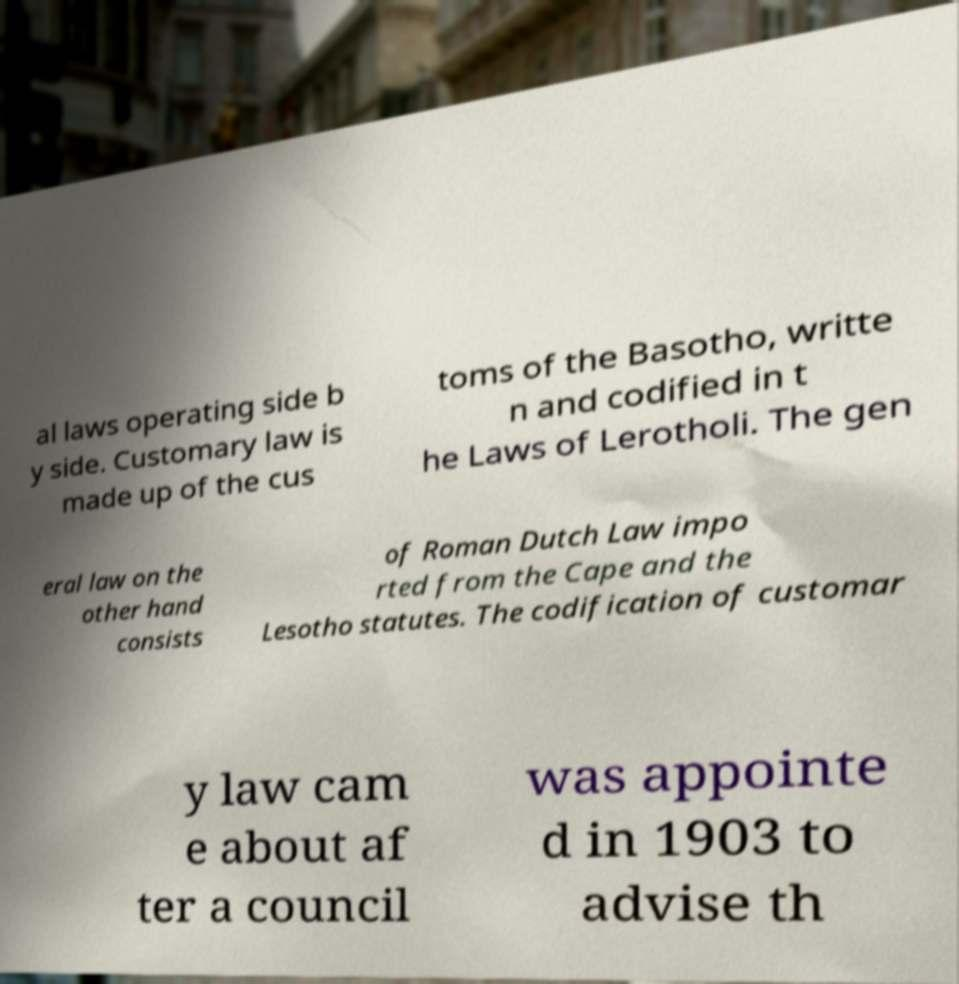Could you extract and type out the text from this image? al laws operating side b y side. Customary law is made up of the cus toms of the Basotho, writte n and codified in t he Laws of Lerotholi. The gen eral law on the other hand consists of Roman Dutch Law impo rted from the Cape and the Lesotho statutes. The codification of customar y law cam e about af ter a council was appointe d in 1903 to advise th 